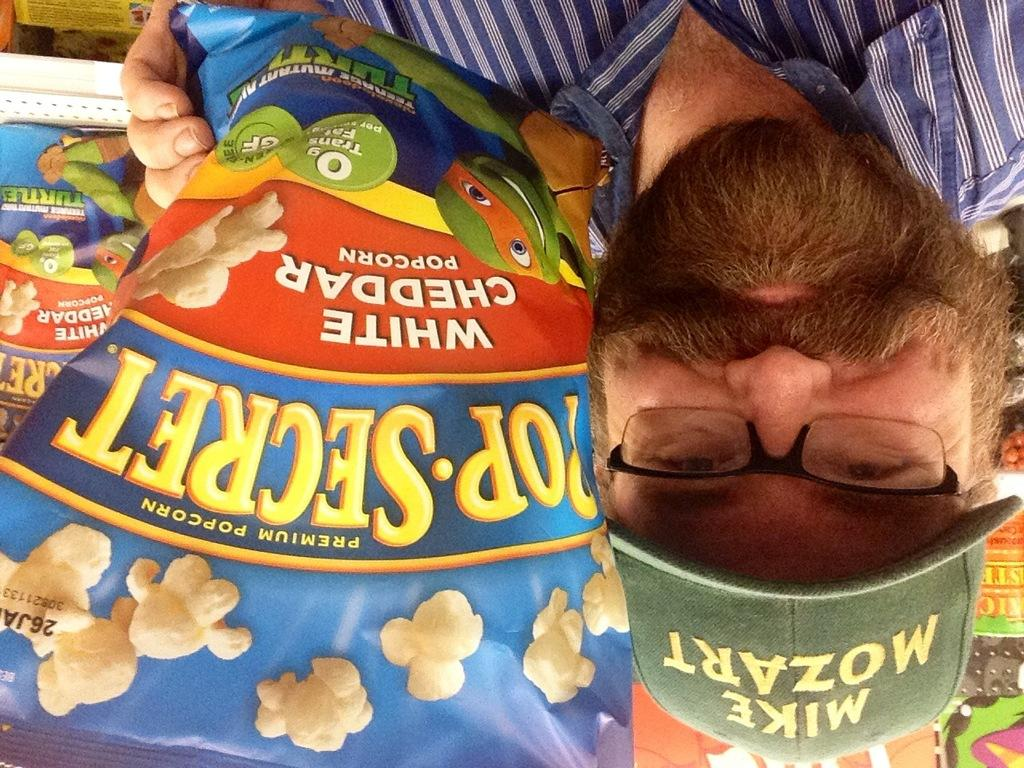Who is present in the image? There is a man in the image. What is the man holding in the image? The man is holding a popcorn packet. What is the man wearing on his head? The man is wearing a cap. What is the man wearing on his face? The man is wearing spectacles. What is the man wearing on his upper body? The man is wearing a shirt. What type of jam is the man spreading on the pies in the image? There is no jam or pies present in the image. The man is holding a popcorn packet and wearing a cap, spectacles, and a shirt. 